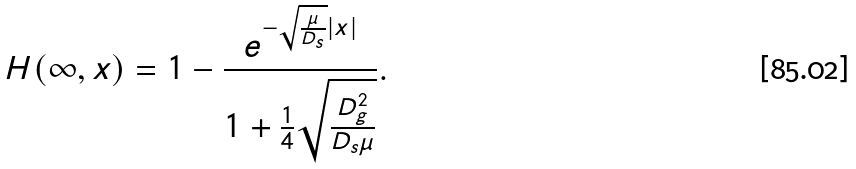Convert formula to latex. <formula><loc_0><loc_0><loc_500><loc_500>H ( \infty , x ) = 1 - \frac { e ^ { - \sqrt { \frac { \mu } { D _ { s } } } | x | } } { 1 + \frac { 1 } { 4 } \sqrt { \frac { D _ { g } ^ { 2 } } { D _ { s } \mu } } } .</formula> 